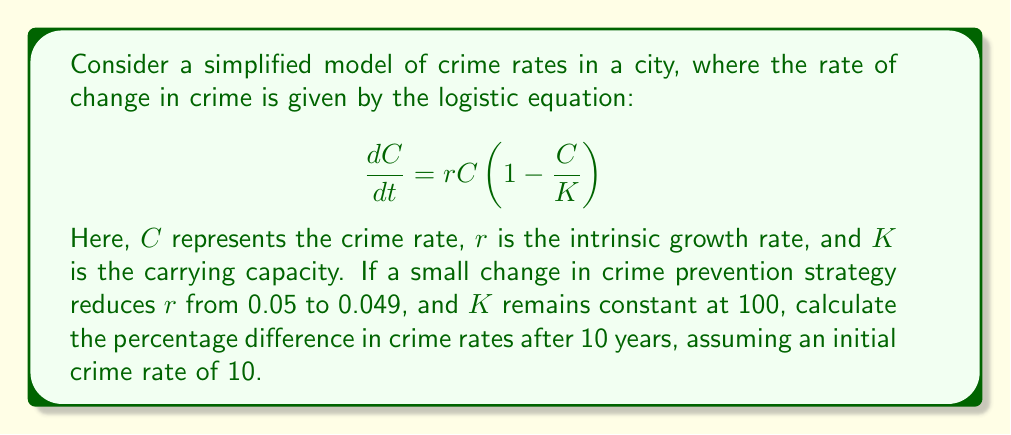What is the answer to this math problem? To solve this problem, we need to use the solution to the logistic equation:

$$C(t) = \frac{KC_0e^{rt}}{K + C_0(e^{rt} - 1)}$$

where $C_0$ is the initial crime rate.

Step 1: Calculate the crime rate after 10 years with r = 0.05
$$C_1(10) = \frac{100 \cdot 10 \cdot e^{0.05 \cdot 10}}{100 + 10(e^{0.05 \cdot 10} - 1)} \approx 16.4439$$

Step 2: Calculate the crime rate after 10 years with r = 0.049
$$C_2(10) = \frac{100 \cdot 10 \cdot e^{0.049 \cdot 10}}{100 + 10(e^{0.049 \cdot 10} - 1)} \approx 16.2795$$

Step 3: Calculate the percentage difference
$$\text{Percentage Difference} = \frac{|C_1(10) - C_2(10)|}{C_1(10)} \cdot 100\%$$
$$= \frac{|16.4439 - 16.2795|}{16.4439} \cdot 100\% \approx 1.0001\%$$

This result demonstrates the butterfly effect in crime prevention strategies, where a small change in the growth rate leads to a noticeable difference in long-term crime rates.
Answer: 1.0001% 